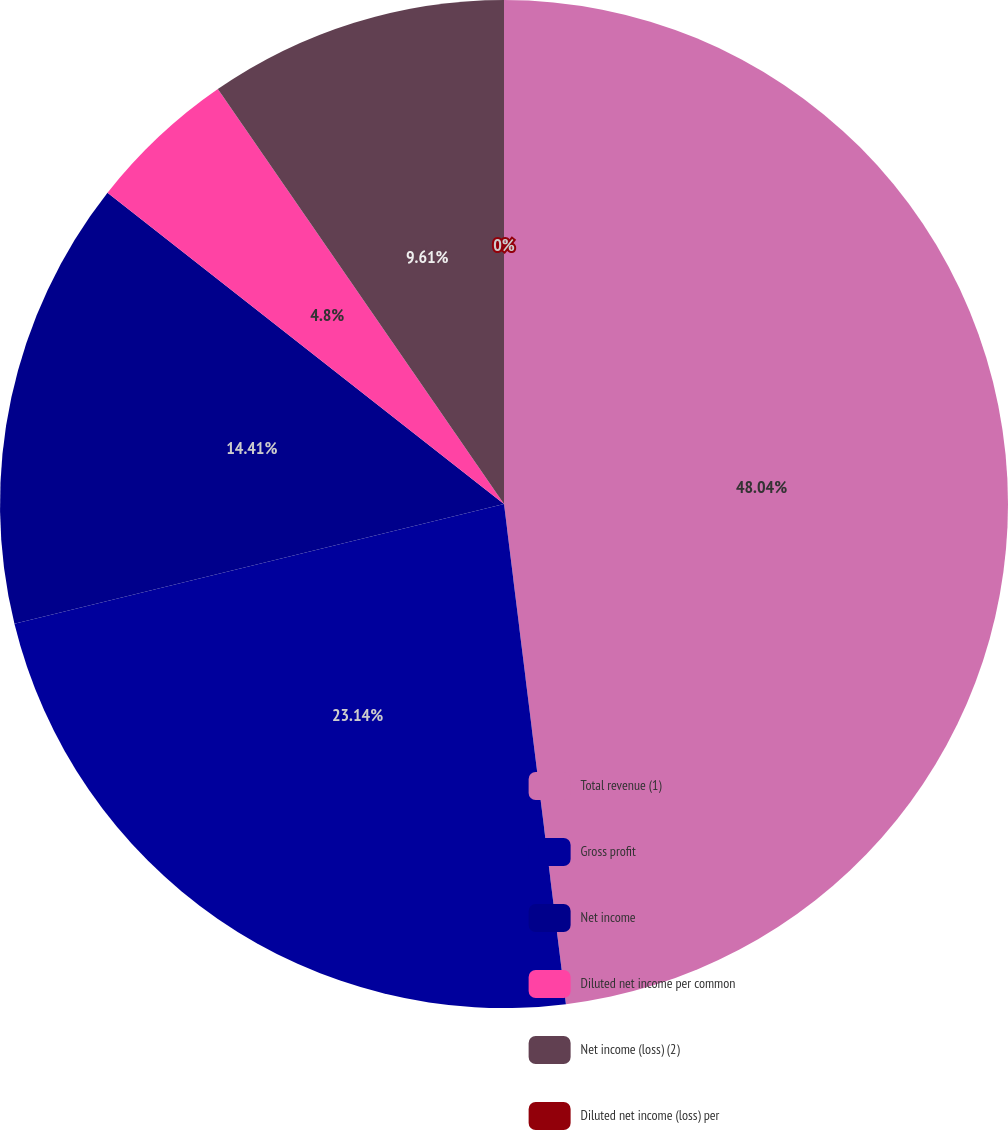Convert chart to OTSL. <chart><loc_0><loc_0><loc_500><loc_500><pie_chart><fcel>Total revenue (1)<fcel>Gross profit<fcel>Net income<fcel>Diluted net income per common<fcel>Net income (loss) (2)<fcel>Diluted net income (loss) per<nl><fcel>48.04%<fcel>23.14%<fcel>14.41%<fcel>4.8%<fcel>9.61%<fcel>0.0%<nl></chart> 